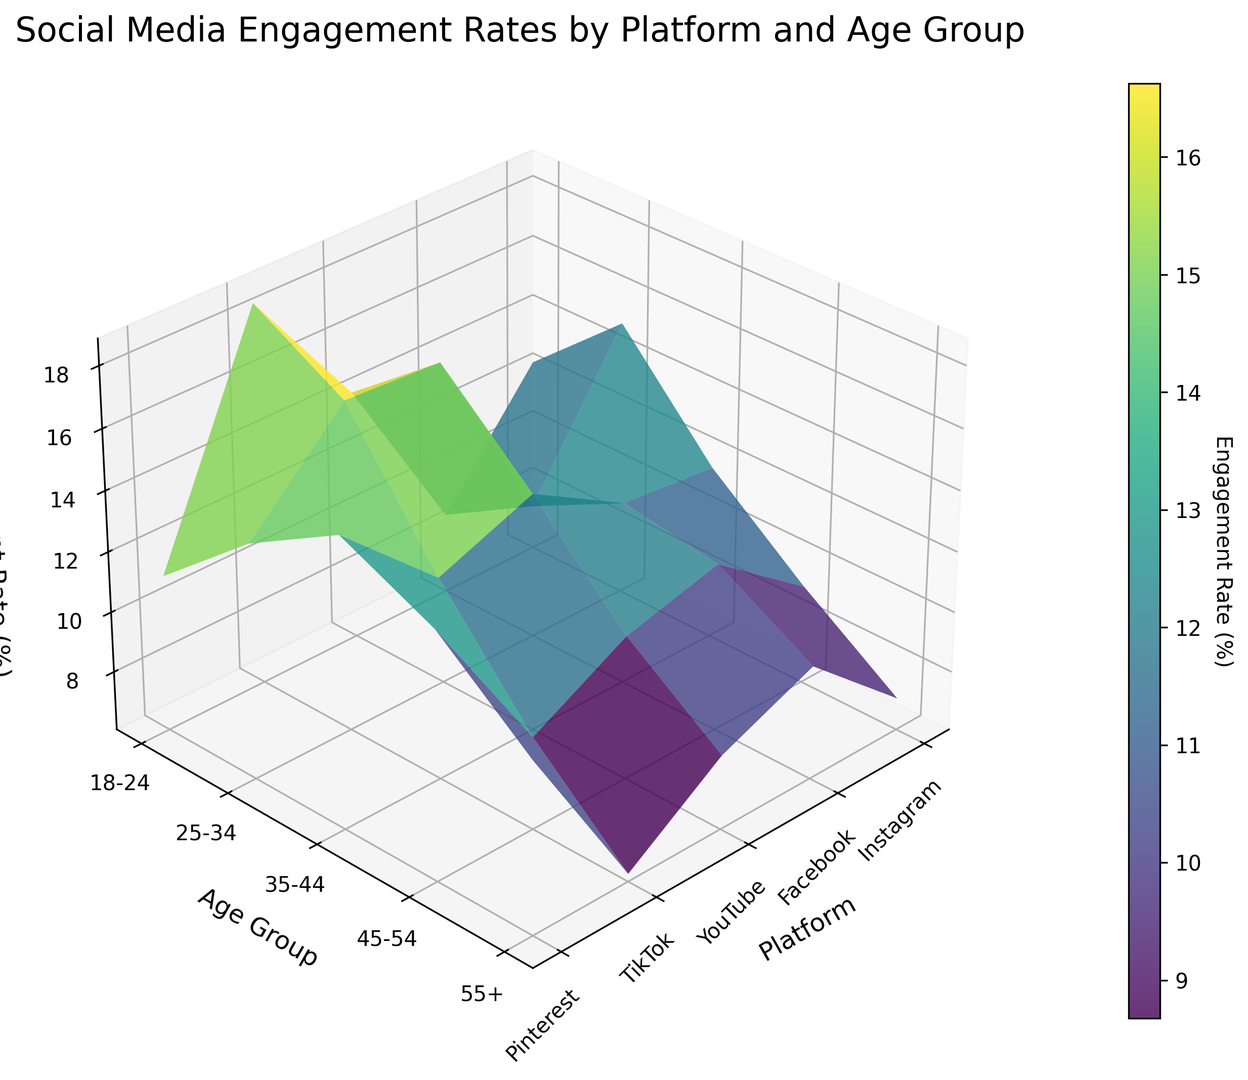which platform has the highest engagement rate for the 18-24 age group? Look at the z-values for the 18-24 age group across all platforms. The highest engagement rate appears as the tallest bar for this age group. TikTok has the tallest bar in this section.
Answer: TikTok how does the engagement rate for Instagram compare between the 18-24 and 25-34 age groups? Compare the heights of the bars for Instagram in both age groups. The bar for the 25-34 age group is slightly taller than the one for the 18-24 age group, indicating a higher engagement rate.
Answer: The 25-34 age group is higher what is the average engagement rate for the 45-54 age group across all platforms? Determine the z-values for the 45-54 age group across all platforms. Add them up and divide by the number of platforms (5), so (9.3 + 11.6 + 10.8 + 9.1 + 14.2) / 5 = 55 / 5.
Answer: 11% which platform shows the largest decrease in engagement rate from the 18-24 to the 55+ age group? Measure the difference in height between the 18-24 and 55+ bars for each platform. Calculate the differences and find the largest: TikTok has the largest decrease (18.6 - 6.3 = 12.3).
Answer: TikTok how does Pinterest's highest engagement rate compare with the highest engagement rate on YouTube? Compare the tallest bars for Pinterest and YouTube. Pinterest's highest is for the 35-44 age group (15.6), while YouTube's highest is for the 25-34 age group (16.7). YouTube's tallest bar is higher.
Answer: YouTube's is higher on which platform does the 25-34 age group have the highest engagement rate? Look for the tallest bar within the 25-34 age group across all platforms. YouTube's bar is the highest in this age group.
Answer: YouTube which age group has the highest engagement rate on Facebook? Identify the tallest bar within the Facebook section. The tallest bar corresponds to the 35-44 age group (12.1).
Answer: 35-44 what is the median engagement rate for Pinterest across all age groups? List Pinterest's engagement rates for all age groups: (11.2, 13.8, 15.6, 14.2, 11.7). The median value is the middle number in this sorted list, which is 13.8.
Answer: 13.8% how does TikTok's engagement rate for the 35-44 age group compare to Instagram's for the same age group? Compare the height of bars for TikTok and Instagram within the 35-44 age group. TikTok's bar (12.7) is slightly higher than Instagram's (11.8).
Answer: TikTok's is higherutb 